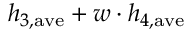<formula> <loc_0><loc_0><loc_500><loc_500>h _ { 3 , a v e } + w \cdot h _ { 4 , a v e }</formula> 